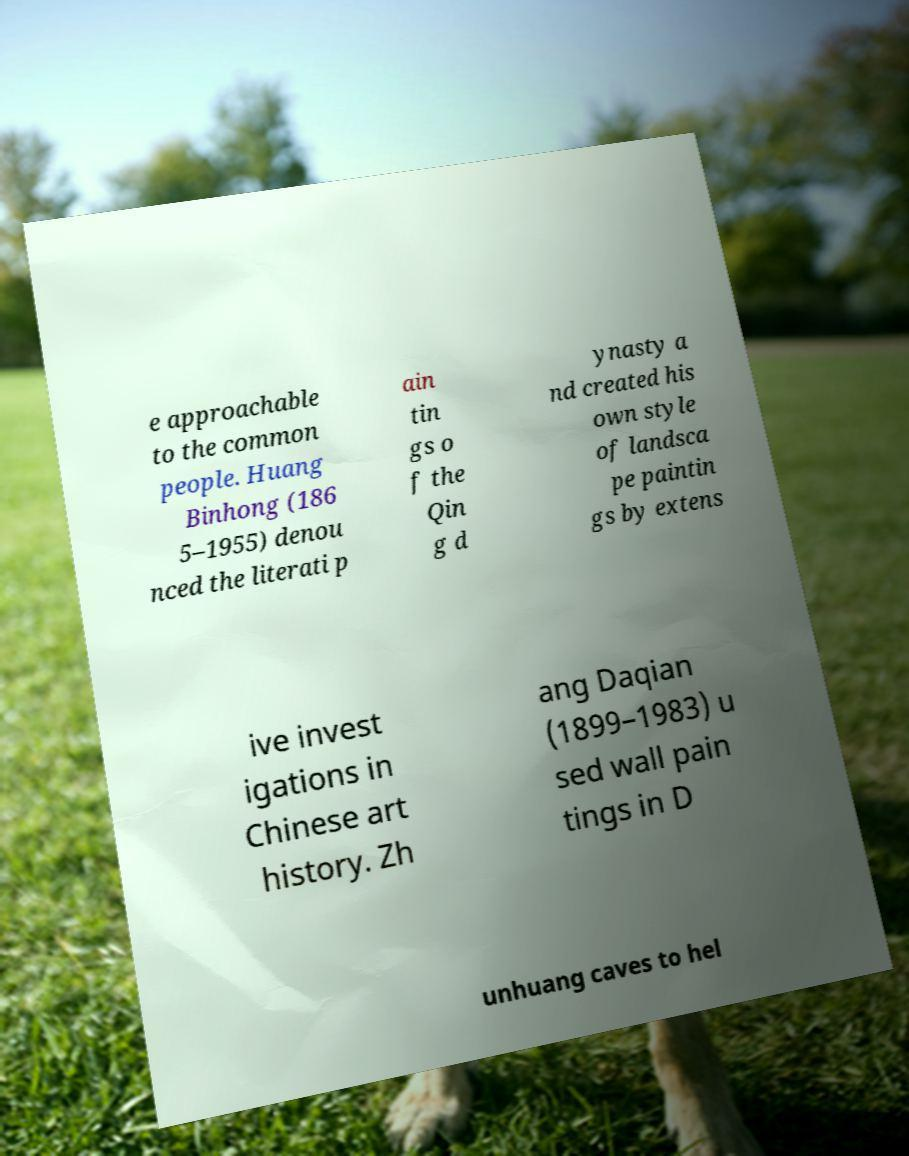For documentation purposes, I need the text within this image transcribed. Could you provide that? e approachable to the common people. Huang Binhong (186 5–1955) denou nced the literati p ain tin gs o f the Qin g d ynasty a nd created his own style of landsca pe paintin gs by extens ive invest igations in Chinese art history. Zh ang Daqian (1899–1983) u sed wall pain tings in D unhuang caves to hel 